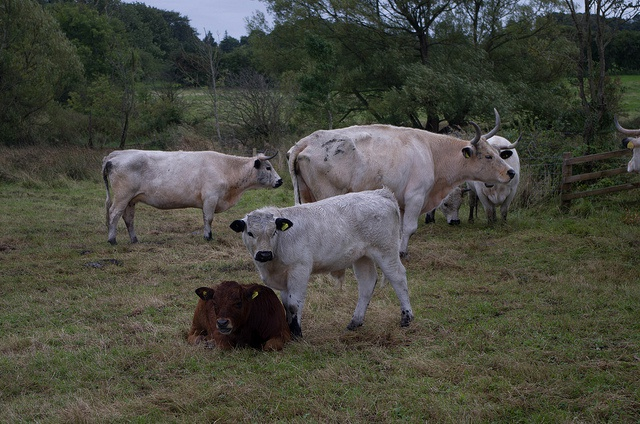Describe the objects in this image and their specific colors. I can see cow in black and gray tones, cow in black, gray, and darkgray tones, cow in black, gray, and darkgray tones, cow in black, maroon, and gray tones, and cow in black, gray, and darkgray tones in this image. 